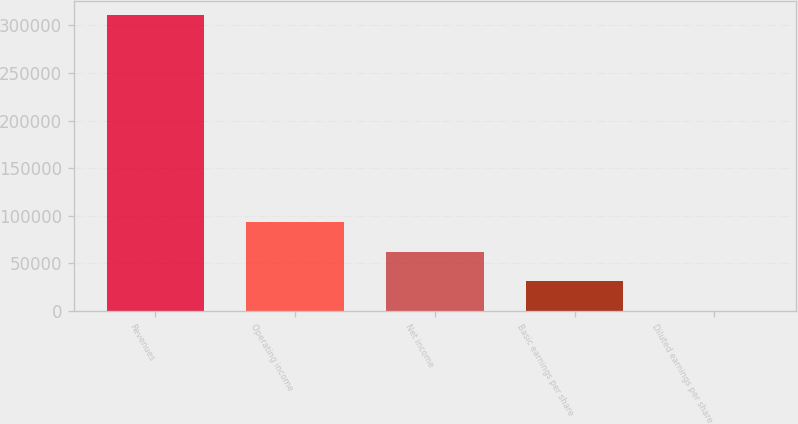<chart> <loc_0><loc_0><loc_500><loc_500><bar_chart><fcel>Revenues<fcel>Operating income<fcel>Net income<fcel>Basic earnings per share<fcel>Diluted earnings per share<nl><fcel>310641<fcel>93192.6<fcel>62128.6<fcel>31064.5<fcel>0.5<nl></chart> 